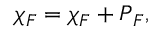Convert formula to latex. <formula><loc_0><loc_0><loc_500><loc_500>\ = \chi _ { \/ F } = \chi _ { \/ F } \ = I + \ = P _ { \/ F } ,</formula> 